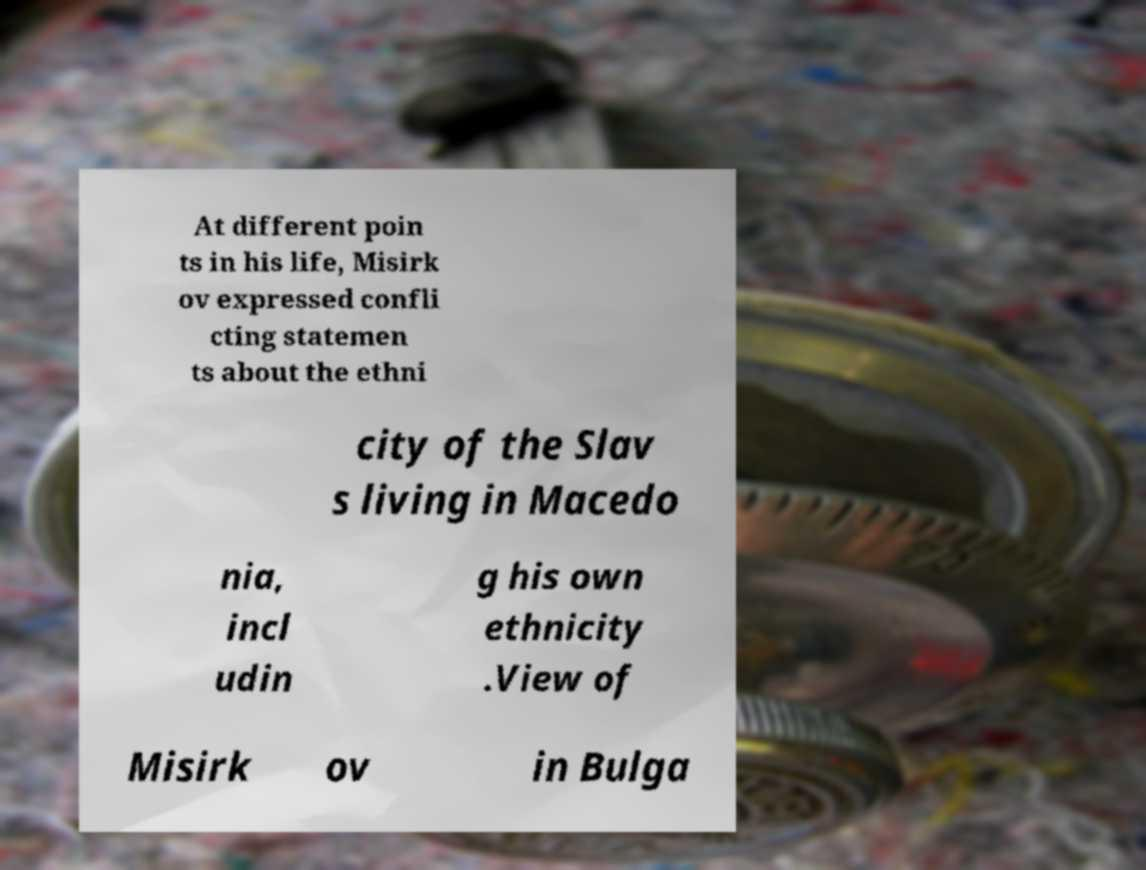What messages or text are displayed in this image? I need them in a readable, typed format. At different poin ts in his life, Misirk ov expressed confli cting statemen ts about the ethni city of the Slav s living in Macedo nia, incl udin g his own ethnicity .View of Misirk ov in Bulga 